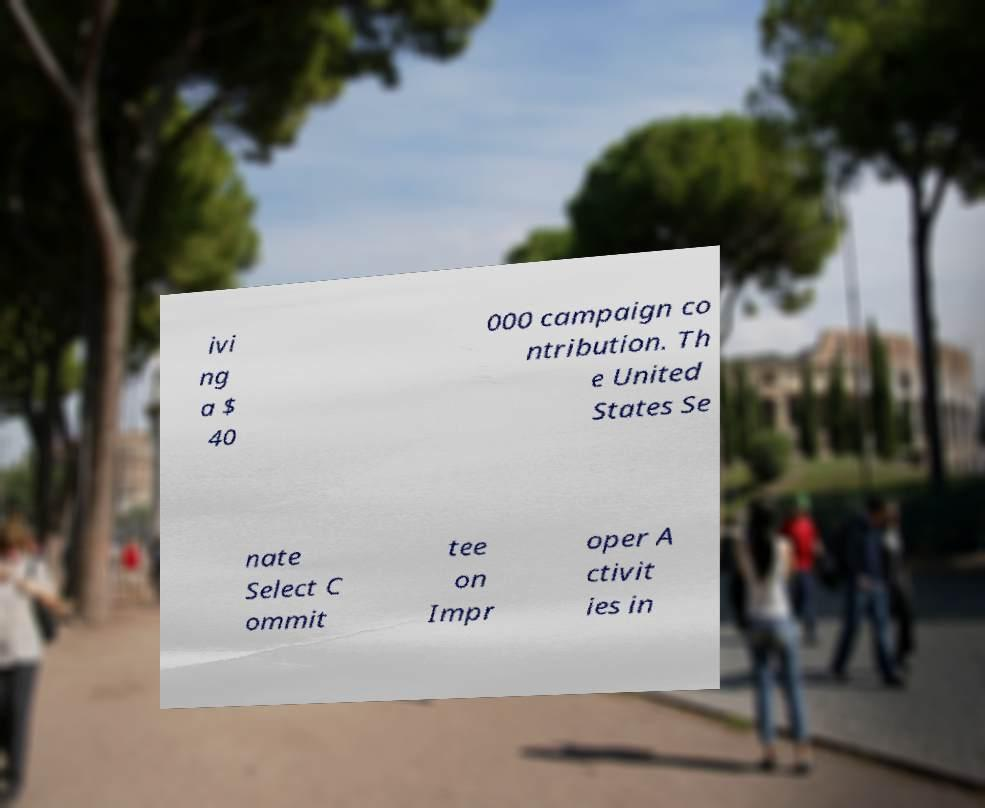There's text embedded in this image that I need extracted. Can you transcribe it verbatim? ivi ng a $ 40 000 campaign co ntribution. Th e United States Se nate Select C ommit tee on Impr oper A ctivit ies in 